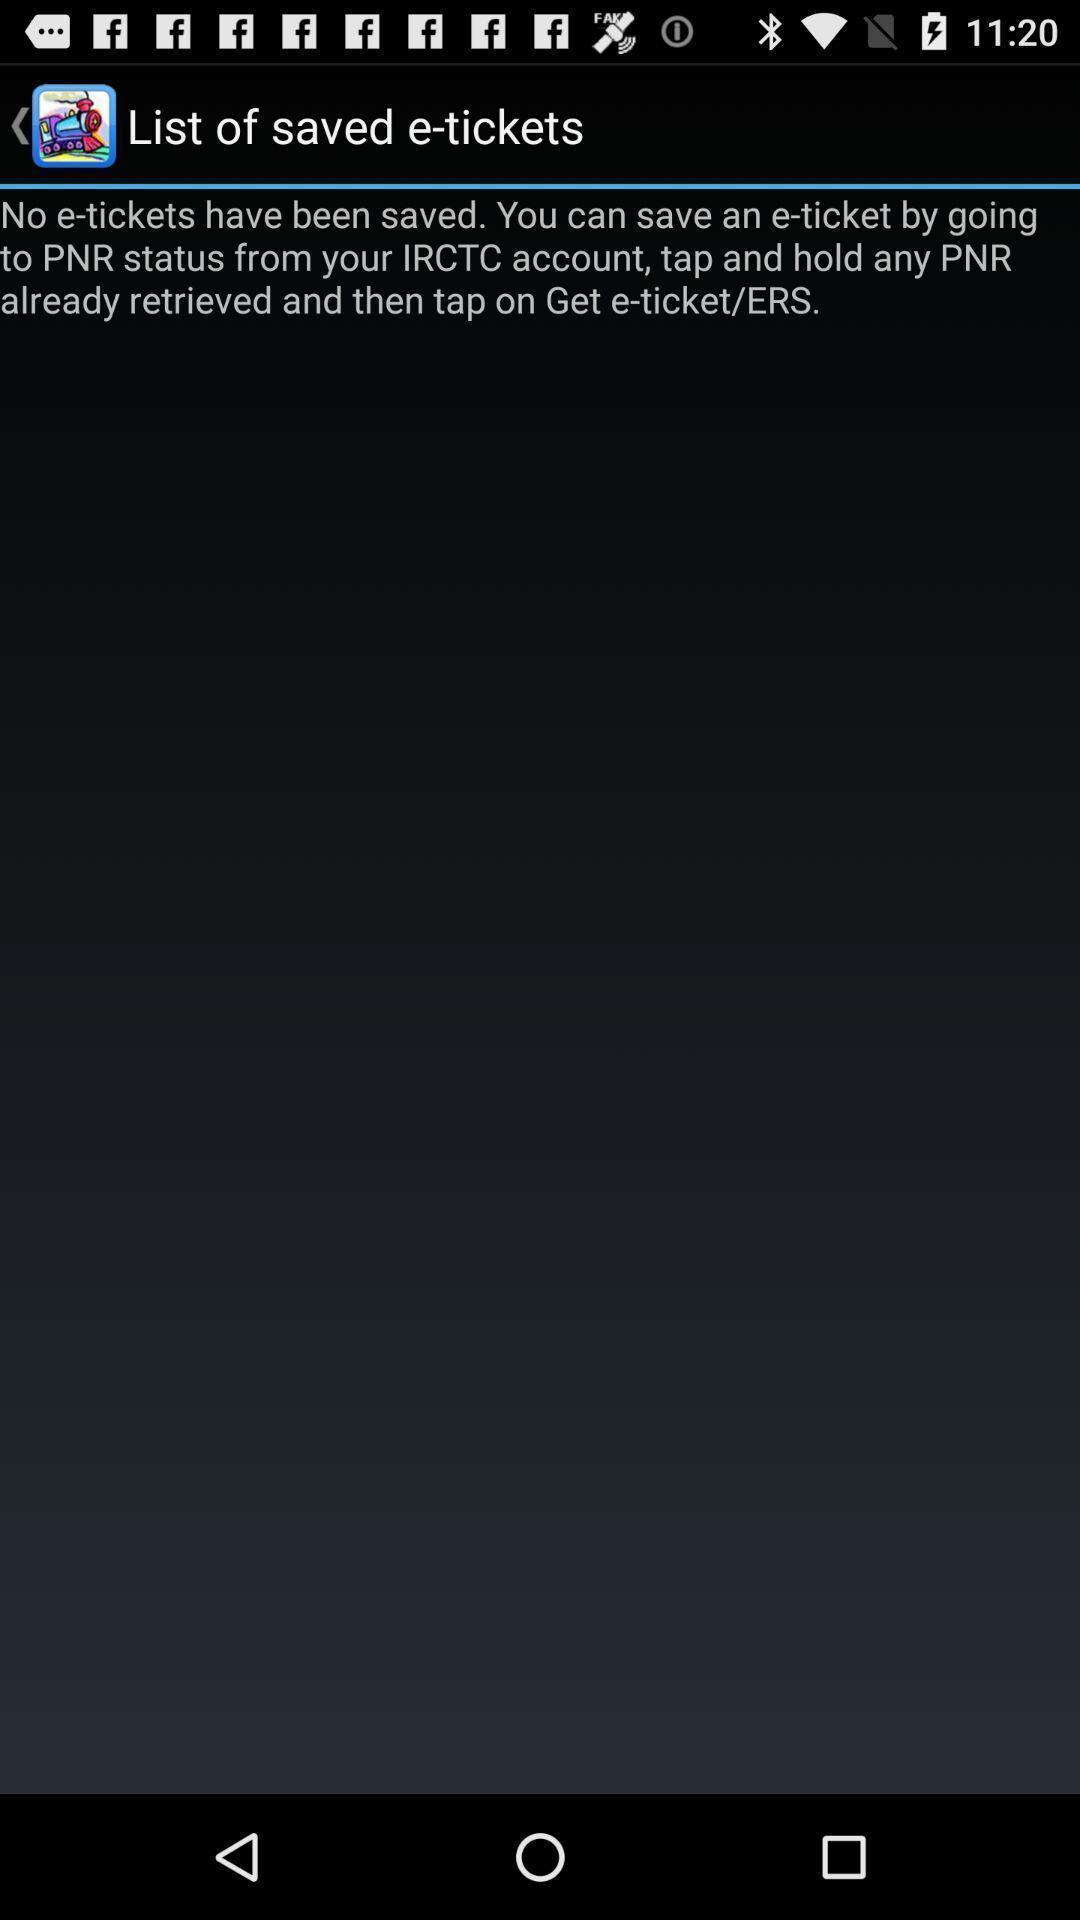Describe the visual elements of this screenshot. Page showing information about tickets. 